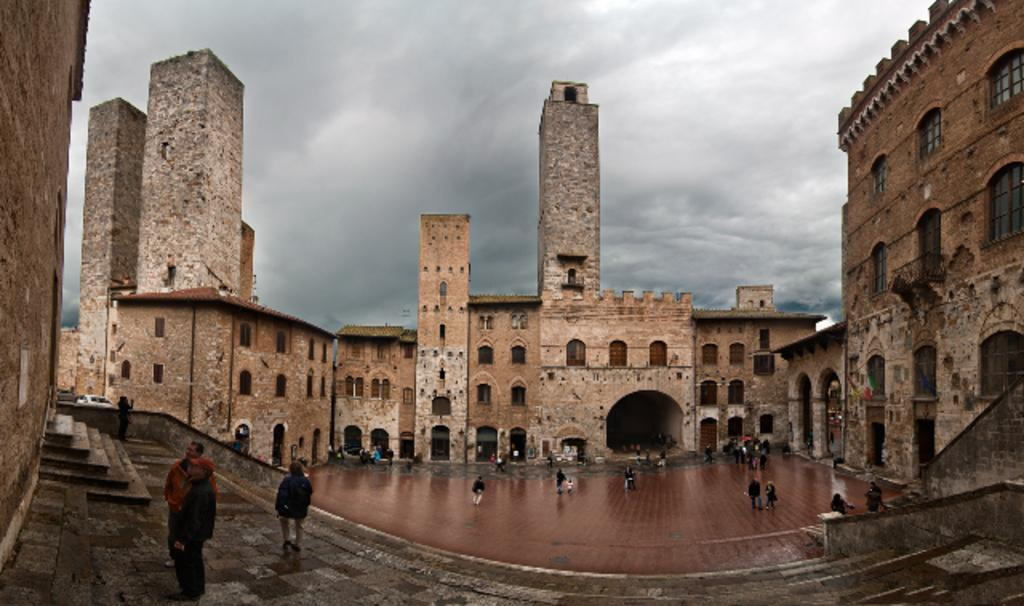What can be seen in the image? There are people standing in the image. Where are the people standing? The people are standing on a floor. What can be seen in the background of the image? There are buildings and the sky visible in the background of the image. How would you describe the sky in the image? The sky appears to be cloudy in the image. What type of teeth can be seen in the image? There are no teeth visible in the image; it features people standing on a floor with buildings and a cloudy sky in the background. 